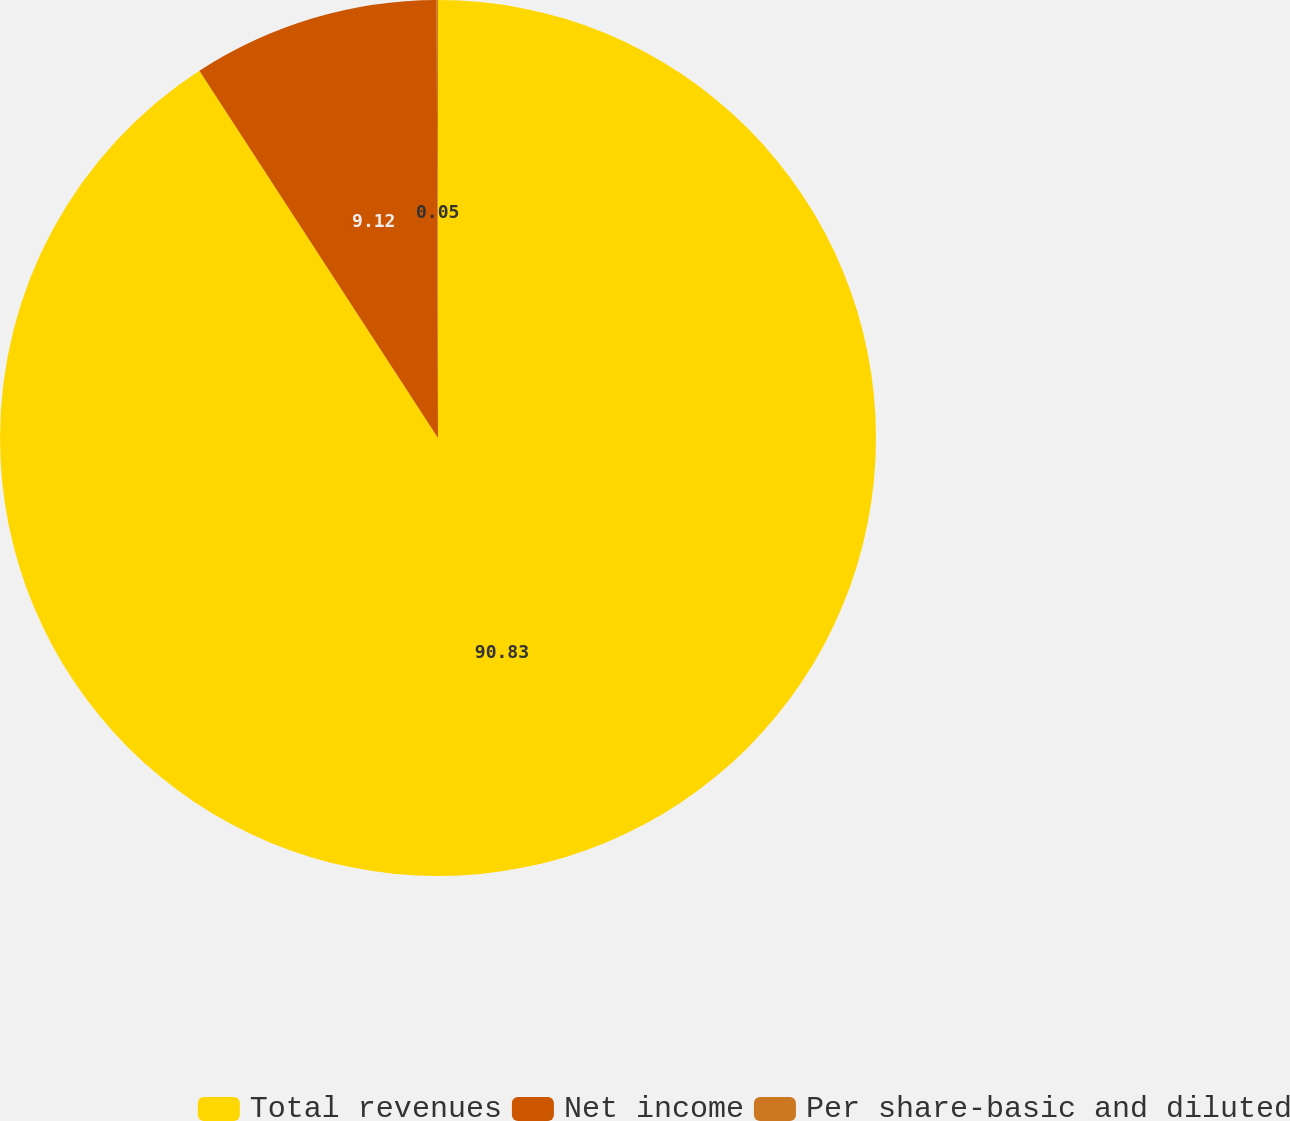Convert chart to OTSL. <chart><loc_0><loc_0><loc_500><loc_500><pie_chart><fcel>Total revenues<fcel>Net income<fcel>Per share-basic and diluted<nl><fcel>90.83%<fcel>9.12%<fcel>0.05%<nl></chart> 